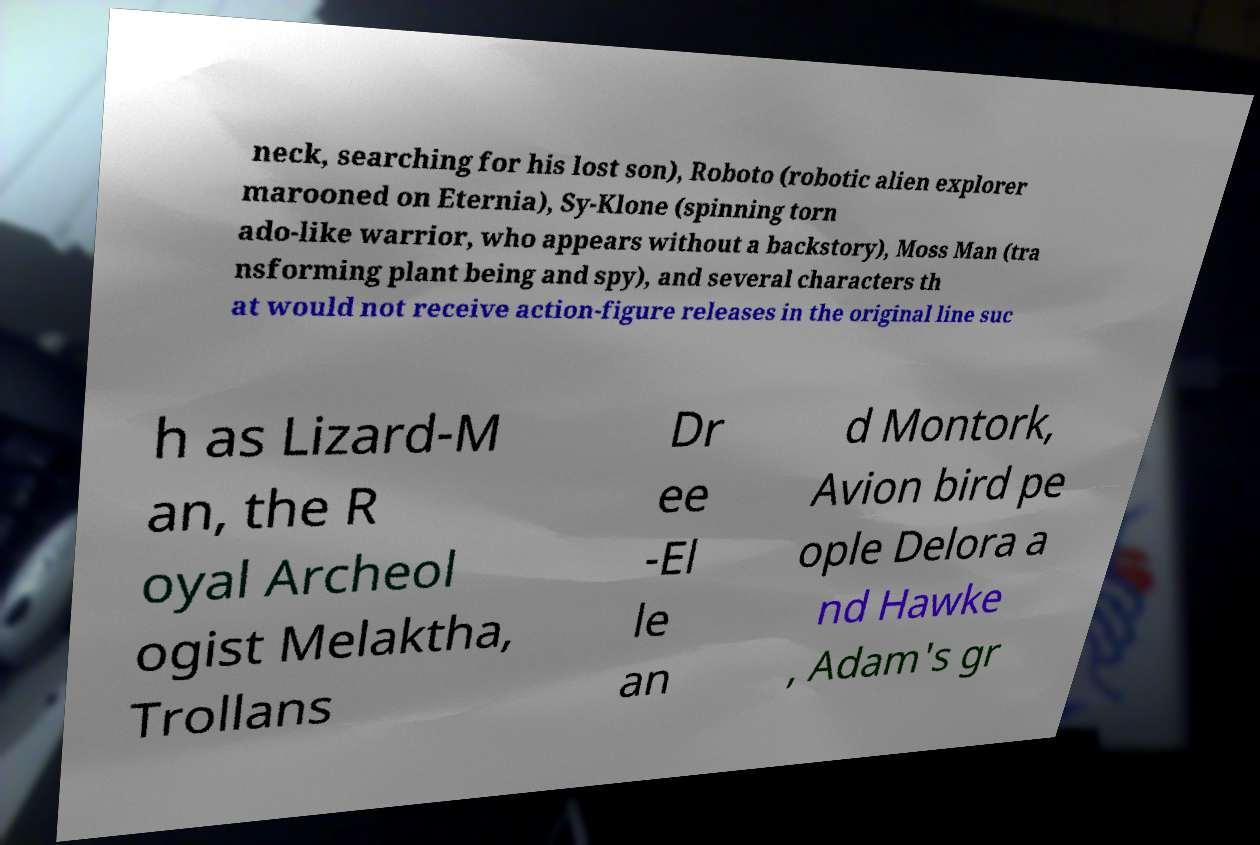I need the written content from this picture converted into text. Can you do that? neck, searching for his lost son), Roboto (robotic alien explorer marooned on Eternia), Sy-Klone (spinning torn ado-like warrior, who appears without a backstory), Moss Man (tra nsforming plant being and spy), and several characters th at would not receive action-figure releases in the original line suc h as Lizard-M an, the R oyal Archeol ogist Melaktha, Trollans Dr ee -El le an d Montork, Avion bird pe ople Delora a nd Hawke , Adam's gr 